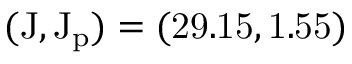Convert formula to latex. <formula><loc_0><loc_0><loc_500><loc_500>( { J } , \mathrm { { J _ { p } } ) = ( 2 9 . 1 5 , 1 . 5 5 ) }</formula> 